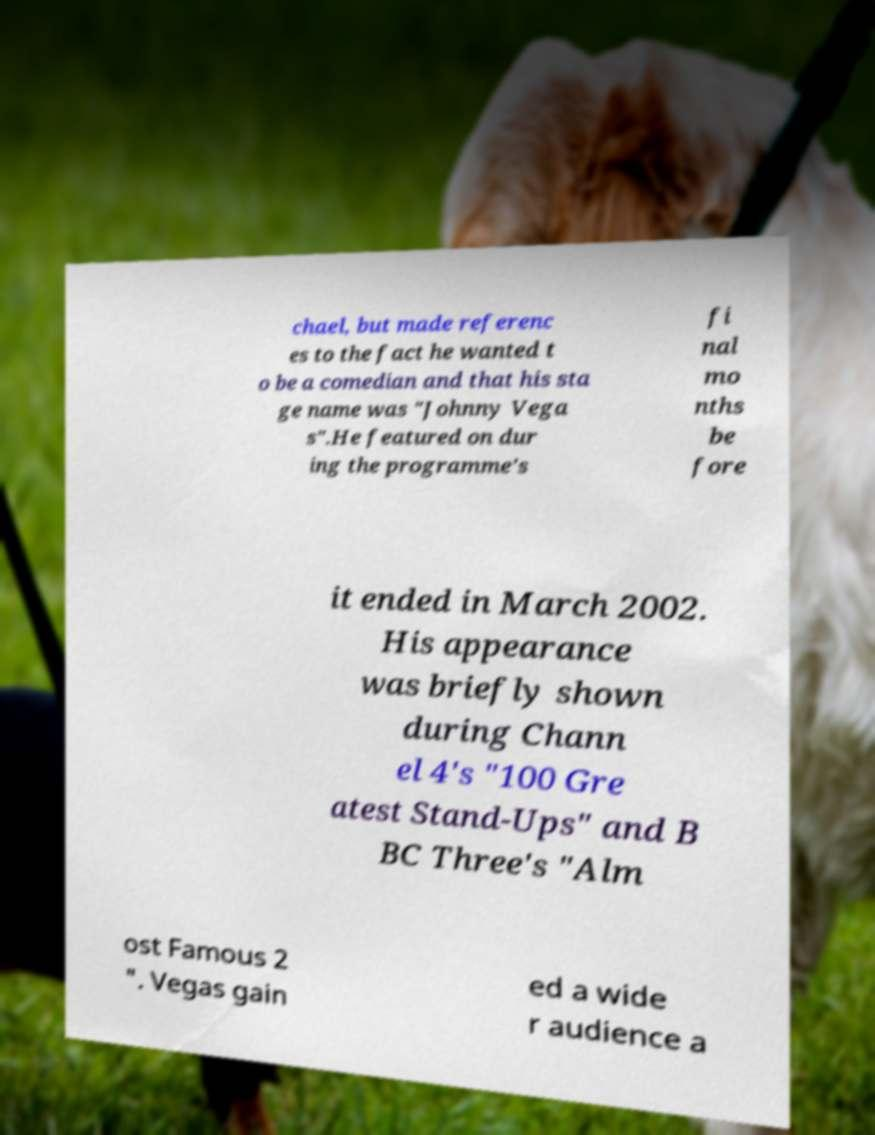Could you assist in decoding the text presented in this image and type it out clearly? chael, but made referenc es to the fact he wanted t o be a comedian and that his sta ge name was "Johnny Vega s".He featured on dur ing the programme's fi nal mo nths be fore it ended in March 2002. His appearance was briefly shown during Chann el 4's "100 Gre atest Stand-Ups" and B BC Three's "Alm ost Famous 2 ". Vegas gain ed a wide r audience a 